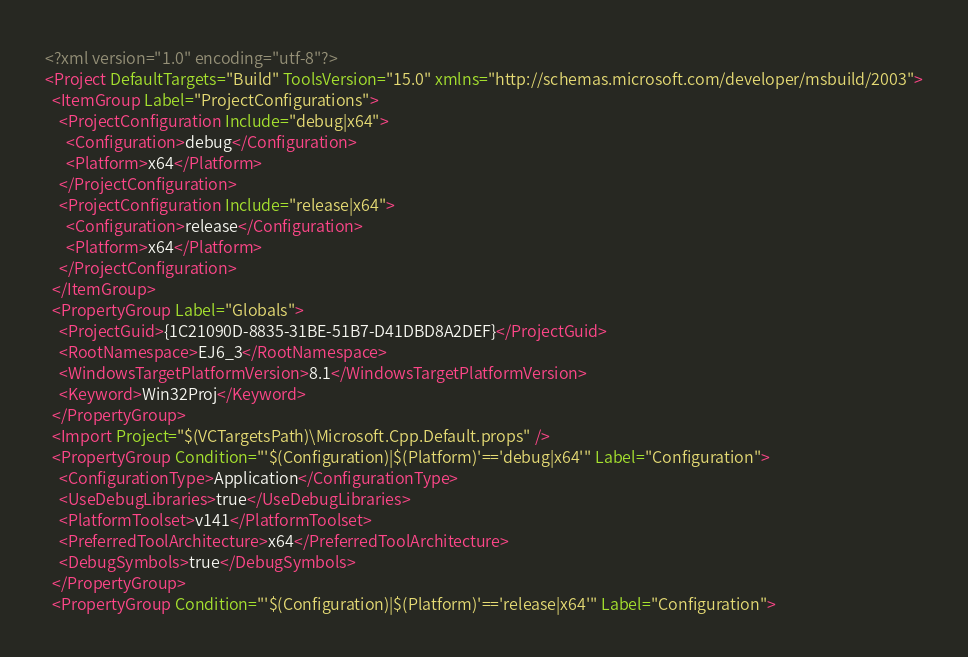Convert code to text. <code><loc_0><loc_0><loc_500><loc_500><_XML_><?xml version="1.0" encoding="utf-8"?>
<Project DefaultTargets="Build" ToolsVersion="15.0" xmlns="http://schemas.microsoft.com/developer/msbuild/2003">
  <ItemGroup Label="ProjectConfigurations">
    <ProjectConfiguration Include="debug|x64">
      <Configuration>debug</Configuration>
      <Platform>x64</Platform>
    </ProjectConfiguration>
    <ProjectConfiguration Include="release|x64">
      <Configuration>release</Configuration>
      <Platform>x64</Platform>
    </ProjectConfiguration>
  </ItemGroup>
  <PropertyGroup Label="Globals">
    <ProjectGuid>{1C21090D-8835-31BE-51B7-D41DBD8A2DEF}</ProjectGuid>
    <RootNamespace>EJ6_3</RootNamespace>
    <WindowsTargetPlatformVersion>8.1</WindowsTargetPlatformVersion>
    <Keyword>Win32Proj</Keyword>
  </PropertyGroup>
  <Import Project="$(VCTargetsPath)\Microsoft.Cpp.Default.props" />
  <PropertyGroup Condition="'$(Configuration)|$(Platform)'=='debug|x64'" Label="Configuration">
    <ConfigurationType>Application</ConfigurationType>
    <UseDebugLibraries>true</UseDebugLibraries>
    <PlatformToolset>v141</PlatformToolset>
    <PreferredToolArchitecture>x64</PreferredToolArchitecture>
    <DebugSymbols>true</DebugSymbols>
  </PropertyGroup>
  <PropertyGroup Condition="'$(Configuration)|$(Platform)'=='release|x64'" Label="Configuration"></code> 